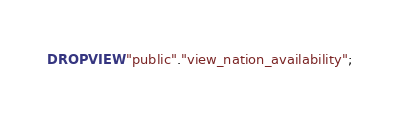<code> <loc_0><loc_0><loc_500><loc_500><_SQL_>DROP VIEW "public"."view_nation_availability";
</code> 